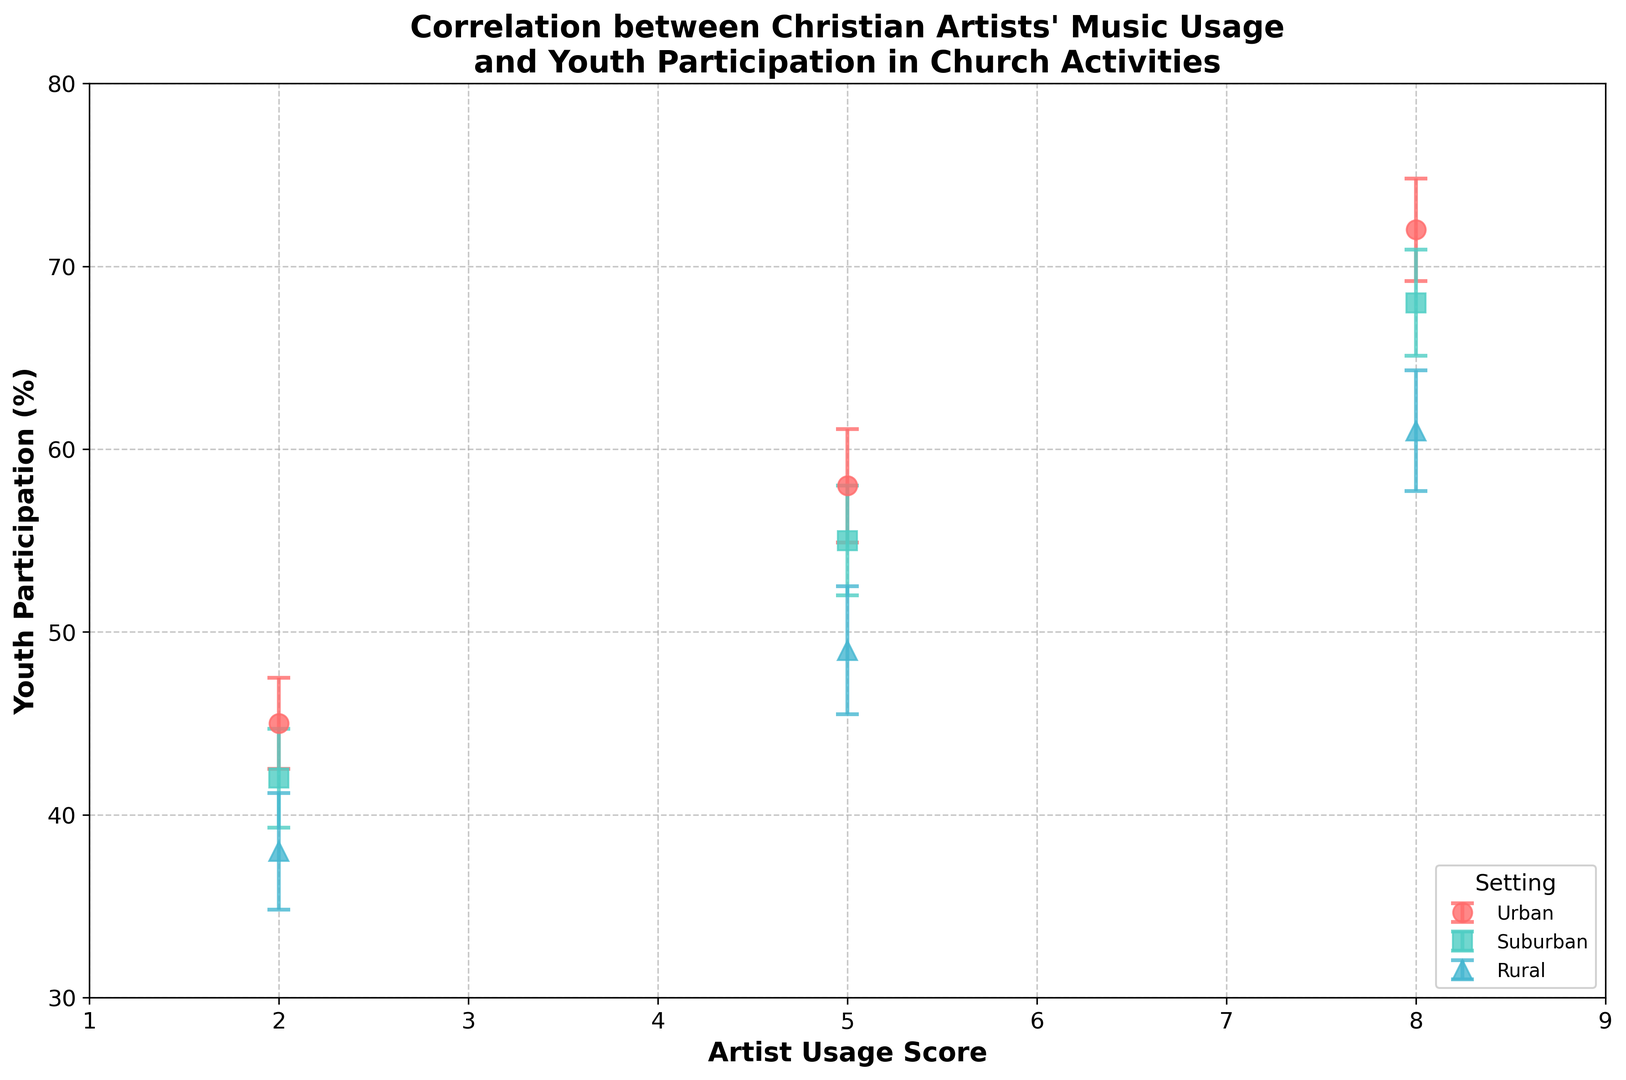What is the youth participation percentage for urban settings with high artist usage scores? Look at the "Urban High" data point on the plot. The y-value (youth participation percentage) for urban settings with an artist usage score of 8 is 72%.
Answer: 72% Which setting has the lowest youth participation percentage with medium artist usage scores? Compare the youth participation percentages for "Urban Medium," "Suburban Medium," and "Rural Medium" data points. The "Rural Medium" setting has the lowest at 49%.
Answer: Rural How does youth participation percentage differ between suburban and rural settings with high artist usage scores? Compare the y-values for "Suburban High" (68%) and "Rural High" (61%). Subtracting 61 from 68 gives a difference of 7%.
Answer: 7% What is the average youth participation percentage for suburban settings at all usage levels? Sum the participation percentages for "Suburban Low" (42%), "Suburban Medium" (55%), and "Suburban High" (68%), which equals 165. Divide by 3 to get the average: 165/3 = 55%.
Answer: 55% Which setting shows the highest increase in youth participation percentage as artist usage score goes from low to high? Calculate the differences across settings: Urban (72-45 = 27%), Suburban (68-42 = 26%), and Rural (61-38 = 23%). Urban has the highest increase of 27%.
Answer: Urban Which setting has the largest standard error for medium artist usage scores? Compare the standard errors for "Urban Medium" (3.1), "Suburban Medium" (3.0), and "Rural Medium" (3.5). The "Rural Medium" setting has the largest standard error at 3.5.
Answer: Rural What color represents the rural settings in the plot? The legend in the plot shows the color associated with each setting. Rural settings are represented by the color, which corresponds to #45B7D1 (blue).
Answer: Blue 